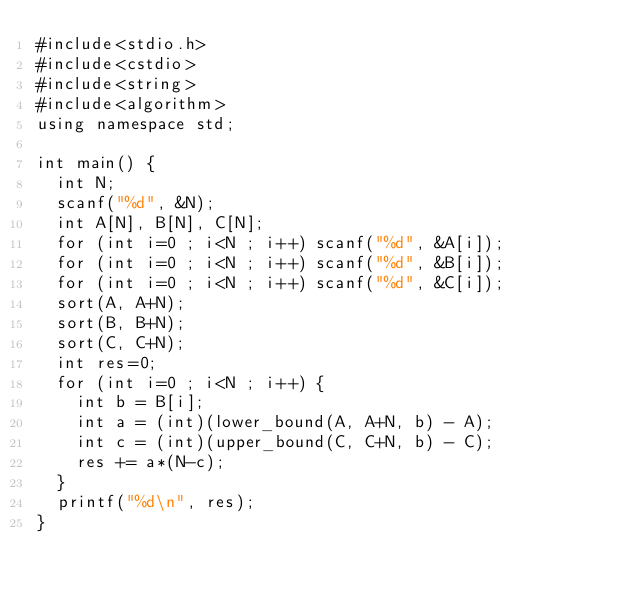<code> <loc_0><loc_0><loc_500><loc_500><_C++_>#include<stdio.h>
#include<cstdio>
#include<string>
#include<algorithm>
using namespace std;

int main() {
  int N;
  scanf("%d", &N);
  int A[N], B[N], C[N];
  for (int i=0 ; i<N ; i++) scanf("%d", &A[i]);
  for (int i=0 ; i<N ; i++) scanf("%d", &B[i]);
  for (int i=0 ; i<N ; i++) scanf("%d", &C[i]);
  sort(A, A+N);
  sort(B, B+N);
  sort(C, C+N);
  int res=0;
  for (int i=0 ; i<N ; i++) {
    int b = B[i];
    int a = (int)(lower_bound(A, A+N, b) - A);
    int c = (int)(upper_bound(C, C+N, b) - C);
    res += a*(N-c);
  }
  printf("%d\n", res);
}</code> 